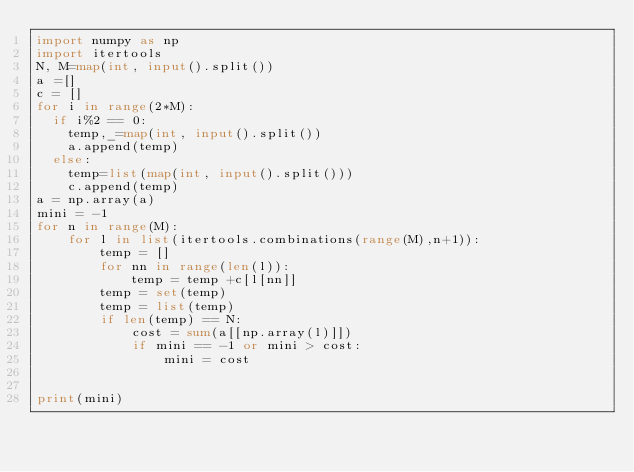Convert code to text. <code><loc_0><loc_0><loc_500><loc_500><_Python_>import numpy as np
import itertools
N, M=map(int, input().split())
a =[]
c = []
for i in range(2*M):
  if i%2 == 0:
    temp,_=map(int, input().split()) 
    a.append(temp)
  else:
    temp=list(map(int, input().split()))
    c.append(temp)
a = np.array(a) 
mini = -1
for n in range(M):
    for l in list(itertools.combinations(range(M),n+1)):
        temp = []
        for nn in range(len(l)):
            temp = temp +c[l[nn]]
        temp = set(temp)
        temp = list(temp)
        if len(temp) == N:
            cost = sum(a[[np.array(l)]])
            if mini == -1 or mini > cost:
                mini = cost


print(mini)  </code> 